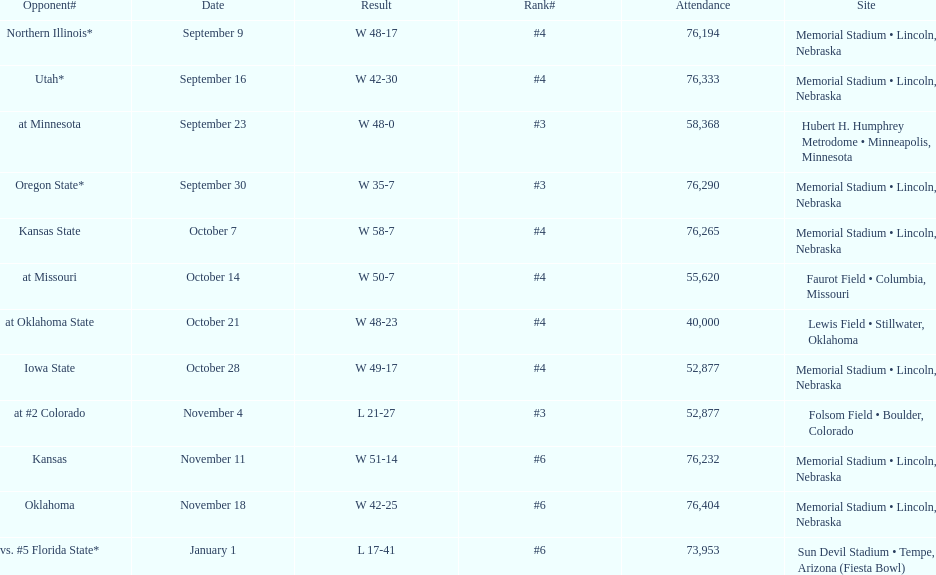What is the next site listed after lewis field? Memorial Stadium • Lincoln, Nebraska. 